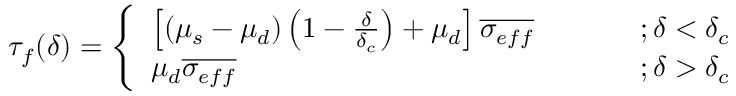<formula> <loc_0><loc_0><loc_500><loc_500>\tau _ { f } ( \delta ) = \left \{ \begin{array} { l l } { \left [ ( \mu _ { s } - \mu _ { d } ) \left ( 1 - \frac { \delta } { \delta _ { c } } \right ) + \mu _ { d } \right ] \overline { { \sigma _ { e f f } } } } & { ; \delta < \delta _ { c } } \\ { \mu _ { d } \overline { { \sigma _ { e f f } } } } & { ; \delta > \delta _ { c } } \end{array}</formula> 